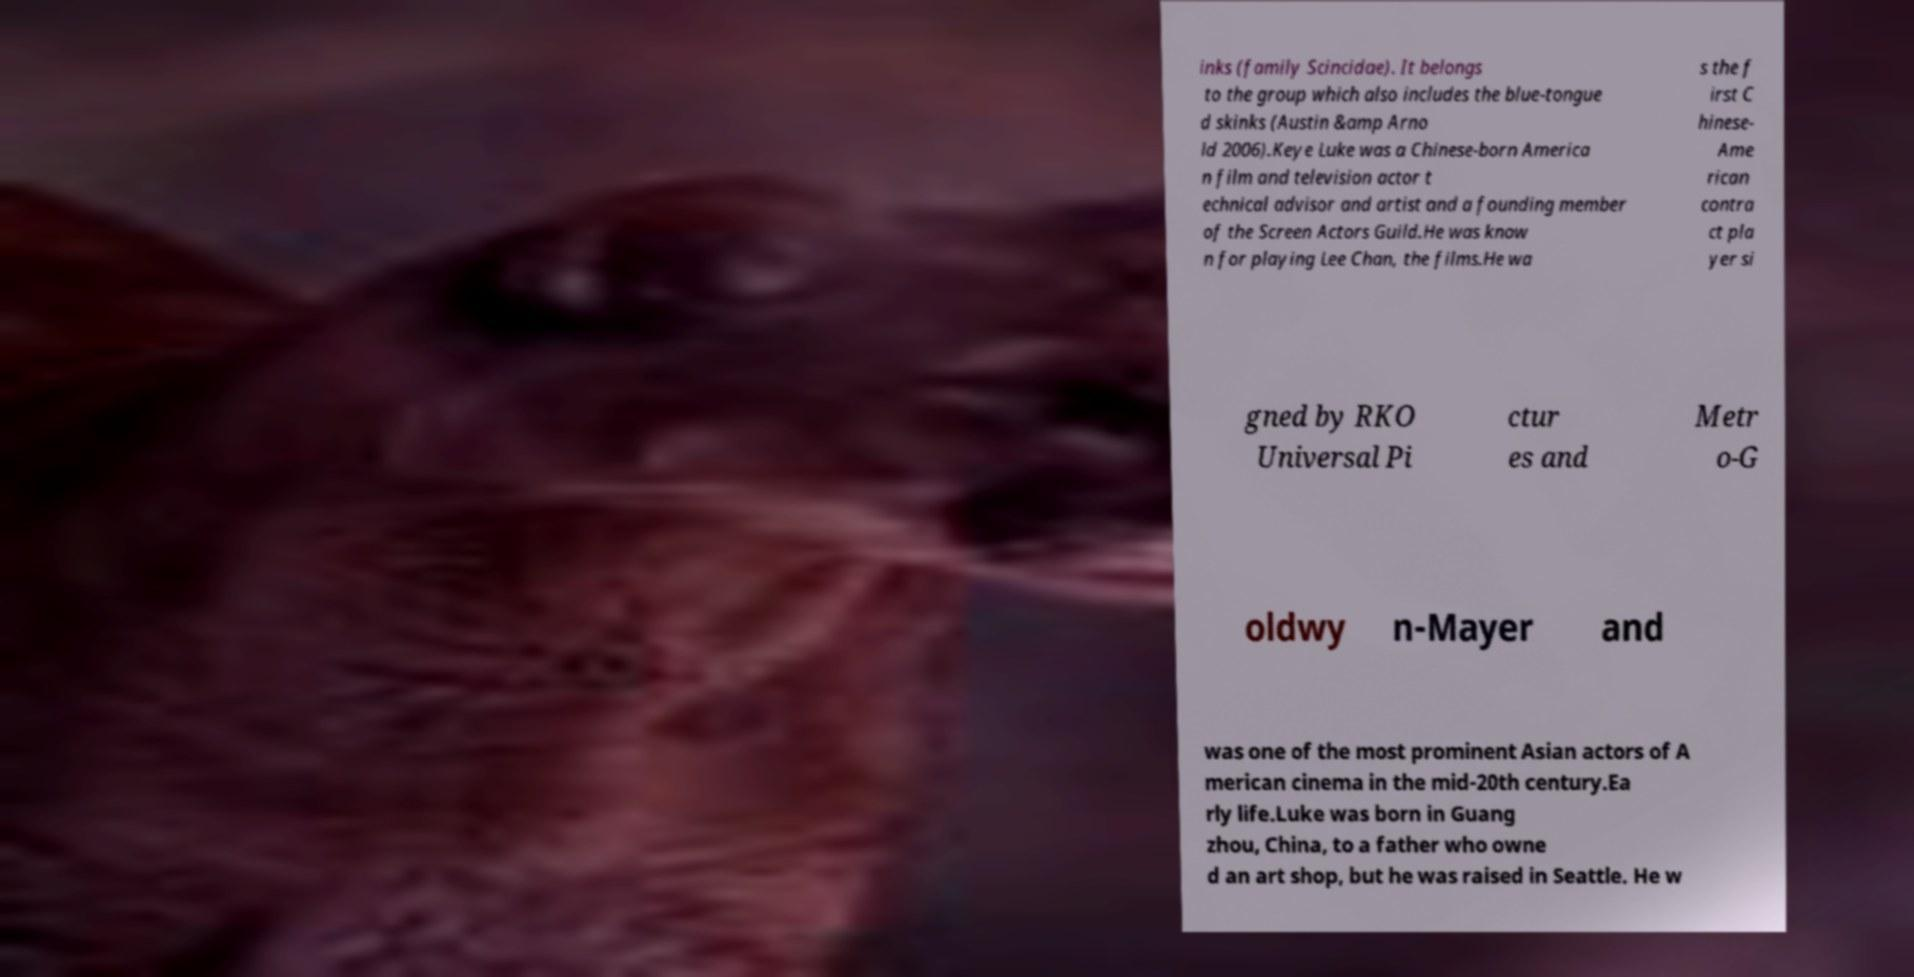Could you extract and type out the text from this image? inks (family Scincidae). It belongs to the group which also includes the blue-tongue d skinks (Austin &amp Arno ld 2006).Keye Luke was a Chinese-born America n film and television actor t echnical advisor and artist and a founding member of the Screen Actors Guild.He was know n for playing Lee Chan, the films.He wa s the f irst C hinese- Ame rican contra ct pla yer si gned by RKO Universal Pi ctur es and Metr o-G oldwy n-Mayer and was one of the most prominent Asian actors of A merican cinema in the mid-20th century.Ea rly life.Luke was born in Guang zhou, China, to a father who owne d an art shop, but he was raised in Seattle. He w 